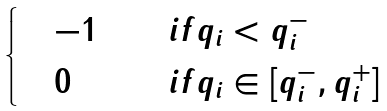Convert formula to latex. <formula><loc_0><loc_0><loc_500><loc_500>\begin{cases} \quad - 1 & \quad i f q _ { i } < q ^ { - } _ { i } \\ \quad 0 & \quad i f q _ { i } \in [ q ^ { - } _ { i } , q ^ { + } _ { i } ] \end{cases}</formula> 